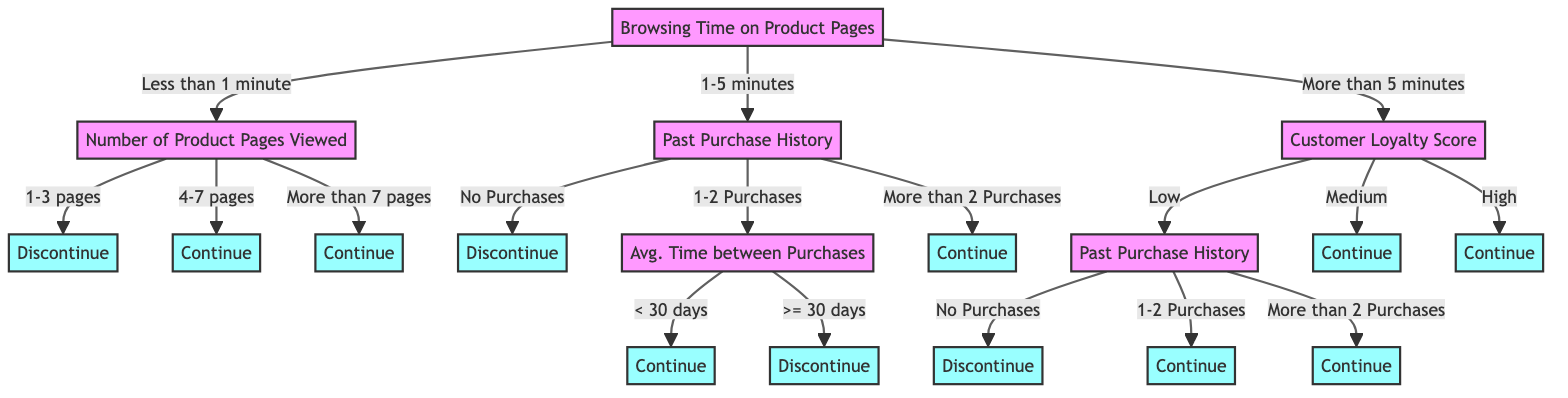What is the first decision node in the tree? The first decision node in the tree is based on "Browsing Time on Product Pages," which is the starting point for determining the outcome.
Answer: Browsing Time on Product Pages How many categories are there for "Browsing Time on Product Pages"? There are three categories for "Browsing Time on Product Pages": Less than 1 minute, 1-5 minutes, and More than 5 minutes.
Answer: Three What outcome is associated with browsing time of "Less than 1 minute" and viewing "1-3 pages"? The outcome associated with this combination is "Discontinue," indicating that customers in this category are less likely to continue purchases.
Answer: Discontinue If a customer browsed for "More than 5 minutes" and has a "High" loyalty score, what is the outcome? According to the tree, if a customer has browsed for "More than 5 minutes" and has a "High" loyalty score, the outcome is "Continue."
Answer: Continue What is the effect of having "No Purchases" in the "Past Purchase History" when the browsing time is "1-5 minutes"? In this scenario, the result will be "Discontinue," suggesting that customers with no prior purchases are more likely to stop buying if they spent 1-5 minutes browsing.
Answer: Discontinue What average time between purchases leads to a "Continue" outcome when past purchases are minimal (1-2)? An average time between purchases of less than 30 days leads to a "Continue" outcome when the customer has made 1-2 purchases.
Answer: Less than 30 days Which outcome is reached if a customer has a "Medium" loyalty score? When a customer has a "Medium" loyalty score, the outcome is "Continue," indicating that medium loyalty is favorable for ongoing purchases.
Answer: Continue What happens if a customer has "4-7 pages" viewed after browsing for "Less than 1 minute"? The tree indicates that if a customer has viewed 4-7 pages after browsing for less than 1 minute, the outcome will be "Continue."
Answer: Continue 